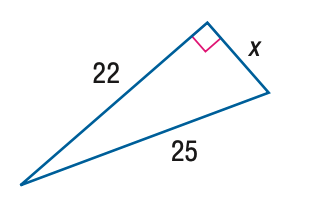Question: Find x.
Choices:
A. 10
B. \sqrt { 141 }
C. 12
D. 7 \sqrt { 3 }
Answer with the letter. Answer: B 